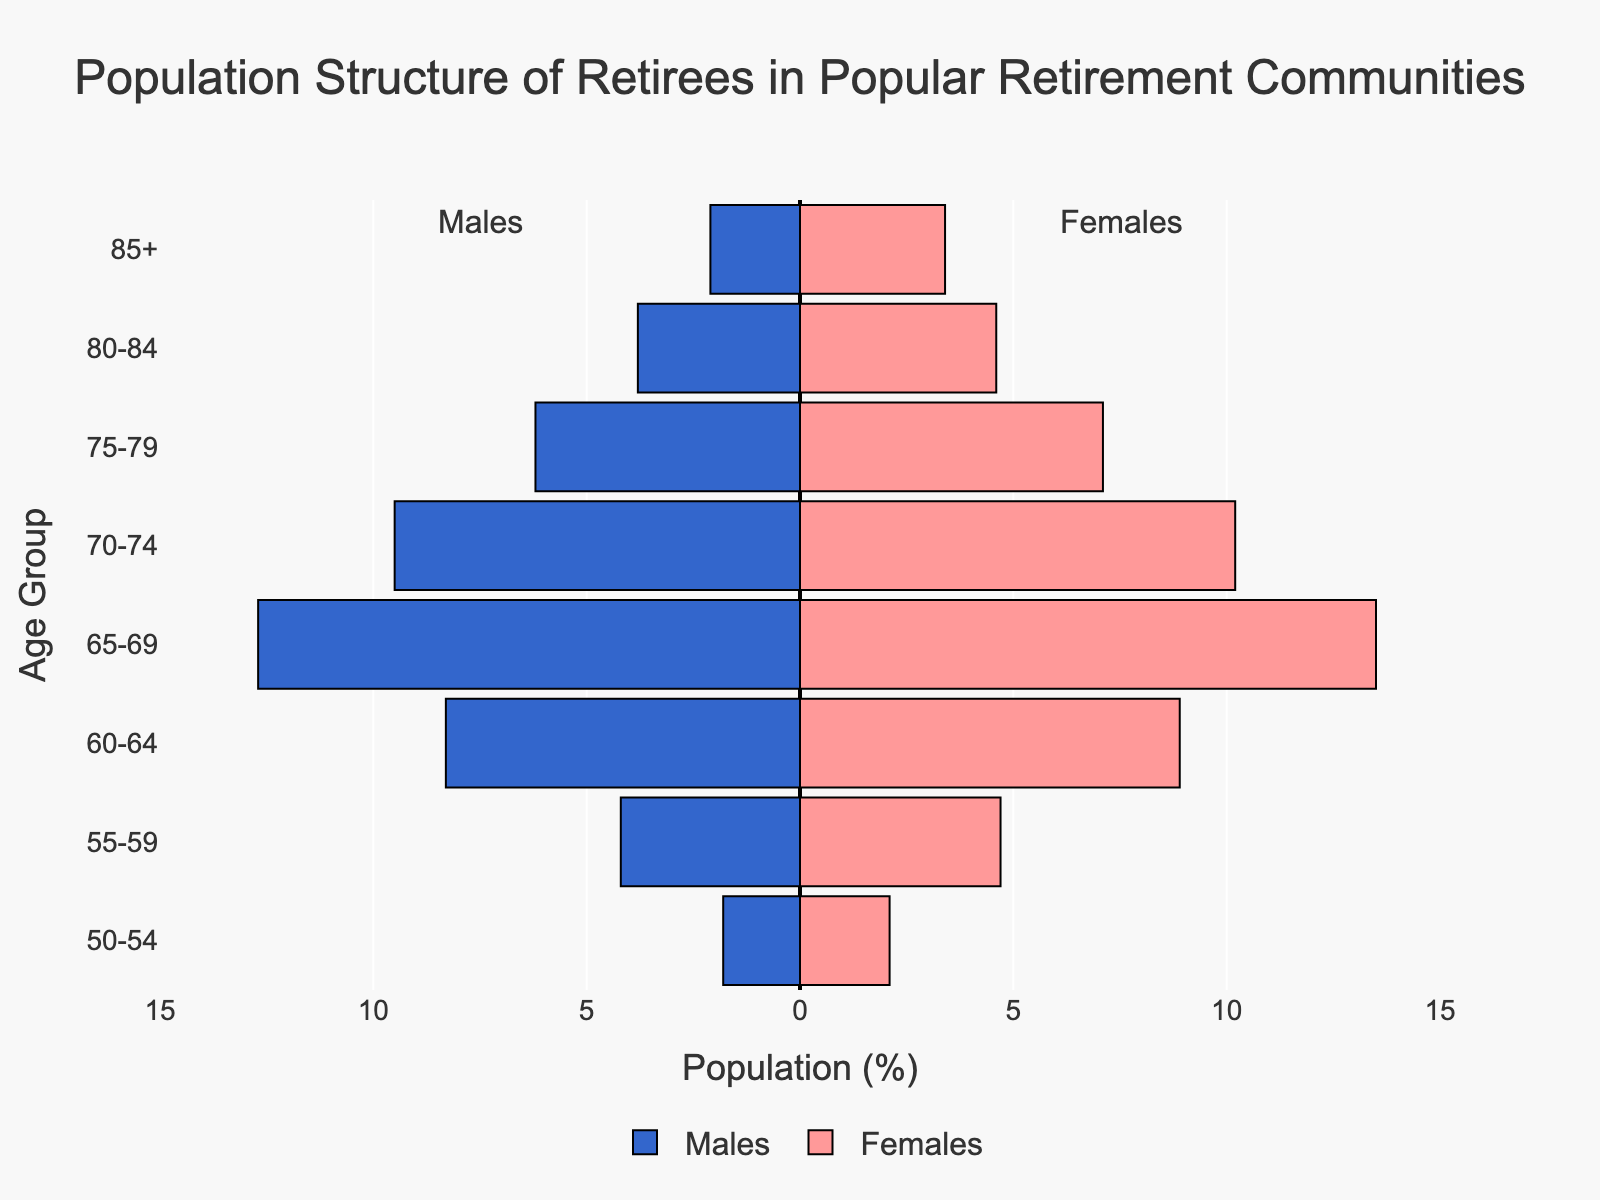What age group has the highest percentage of females? Look at the female population bars and identify the longest one. The longest bar is in the "65-69" age group.
Answer: 65-69 What is the difference in percentage between males and females in the "70-74" age group? Find the length of bars for males and females in the "70-74" age group. The male bar is 9.5 and the female bar is 10.2. The difference is 10.2 - 9.5 = 0.7.
Answer: 0.7 Which gender has a higher population in the "80-84" age group? Compare the lengths of the male and female bars in the "80-84" age group. The female bar is longer at 4.6 compared to the male bar at 3.8.
Answer: Females What is the total percentage of individuals aged 60-64? Sum the percentage of males and females in the "60-64" age group. The male percentage is 8.3 and the female percentage is 8.9. So, the total is 8.3 + 8.9 = 17.2.
Answer: 17.2 How does the population of males in the "55-59" age group compare to the "50-54" age group? Examine the bars for males in both age groups. The bar for "55-59" is 4.2 and for "50-54" is 1.8. Therefore, the population in "55-59" is higher.
Answer: Higher What is the range of ages covered by this population pyramid? Identify the youngest and oldest age groups in the pyramid. The youngest age group is "50-54" and the oldest is "85+."
Answer: 50-85+ Which age group has a more balanced gender distribution? Compare the difference in percentages of males and females across various age groups. The smallest difference is in the "60-64" age group, where males are 8.3 and females are 8.9, giving a difference of 0.6.
Answer: 60-64 Are there more females or males in the "85+" age group? Compare the lengths of the bars for males and females in the "85+" age group. The female bar is longer at 3.4 compared to the male bar at 2.1.
Answer: Females 